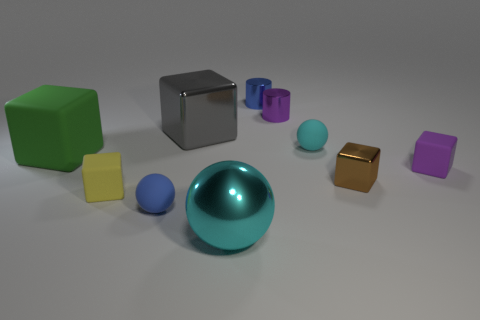Subtract 2 cubes. How many cubes are left? 3 Subtract all small purple rubber cubes. How many cubes are left? 4 Subtract all brown cubes. How many cubes are left? 4 Subtract all blue blocks. Subtract all red cylinders. How many blocks are left? 5 Subtract all balls. How many objects are left? 7 Subtract 1 purple cubes. How many objects are left? 9 Subtract all tiny cyan rubber things. Subtract all tiny brown things. How many objects are left? 8 Add 7 tiny cyan balls. How many tiny cyan balls are left? 8 Add 3 small purple objects. How many small purple objects exist? 5 